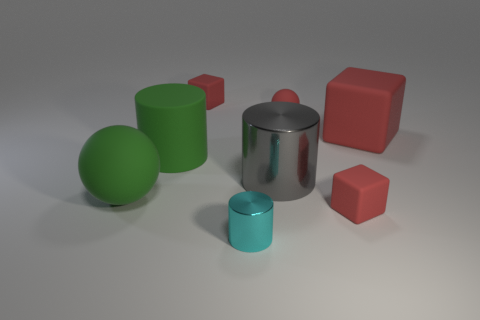How many objects are either tiny red things that are on the left side of the tiny rubber ball or matte cubes in front of the big rubber ball?
Your answer should be compact. 2. How many other things are there of the same color as the large sphere?
Offer a very short reply. 1. Is the number of big matte objects that are to the right of the cyan shiny object greater than the number of large metal cylinders to the left of the green cylinder?
Your answer should be very brief. Yes. What number of balls are green objects or small rubber objects?
Make the answer very short. 2. What number of objects are either small red matte things that are in front of the large matte ball or brown blocks?
Offer a terse response. 1. What shape is the big matte object to the right of the small red block left of the small red rubber thing that is in front of the red rubber ball?
Ensure brevity in your answer.  Cube. How many gray metal things are the same shape as the cyan metal thing?
Make the answer very short. 1. What material is the thing that is the same color as the large matte cylinder?
Your response must be concise. Rubber. Do the large red object and the large ball have the same material?
Your answer should be very brief. Yes. How many red rubber blocks are in front of the red object on the right side of the tiny cube that is on the right side of the tiny red matte sphere?
Your response must be concise. 1. 